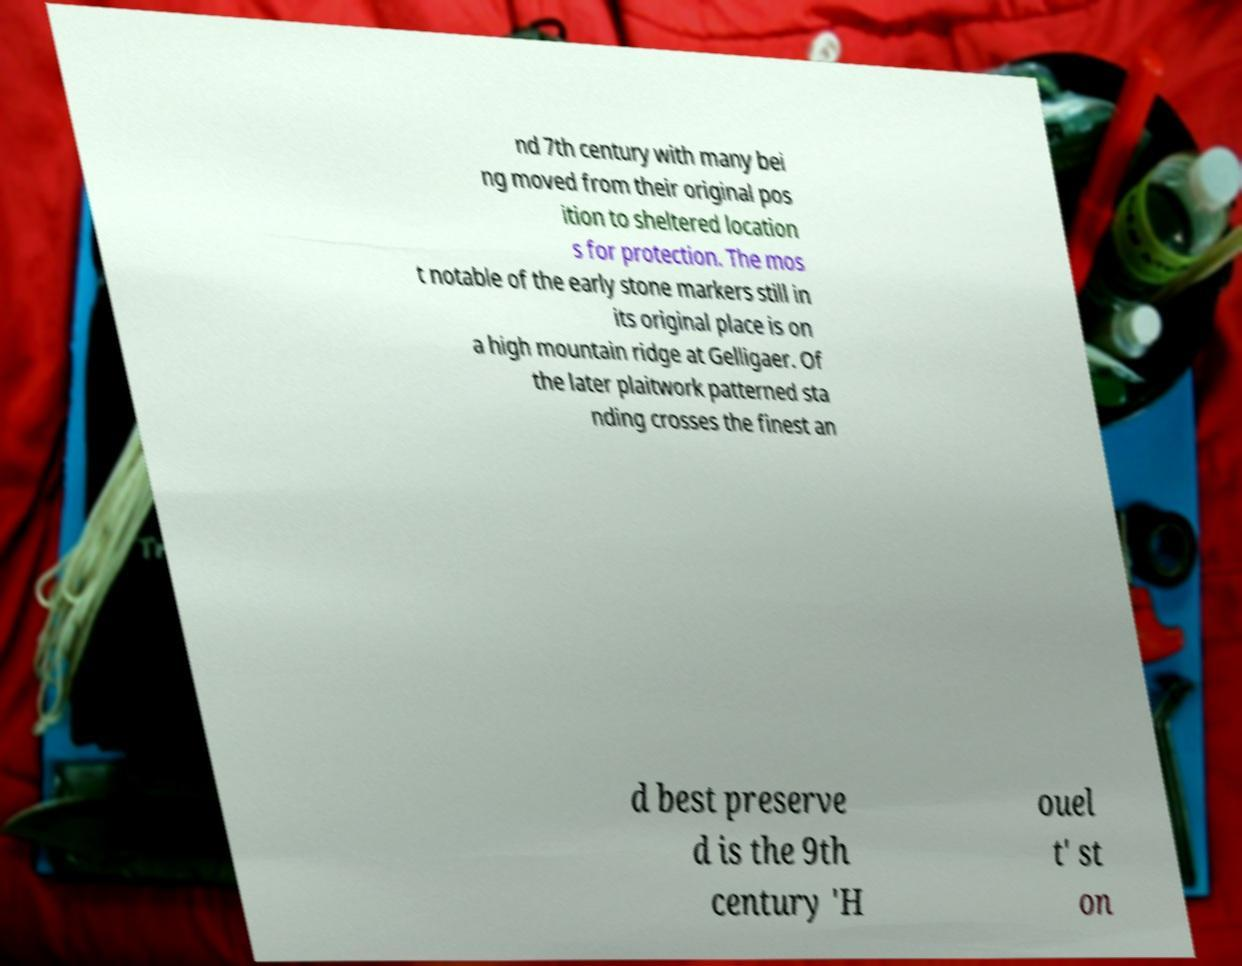There's text embedded in this image that I need extracted. Can you transcribe it verbatim? nd 7th century with many bei ng moved from their original pos ition to sheltered location s for protection. The mos t notable of the early stone markers still in its original place is on a high mountain ridge at Gelligaer. Of the later plaitwork patterned sta nding crosses the finest an d best preserve d is the 9th century 'H ouel t' st on 